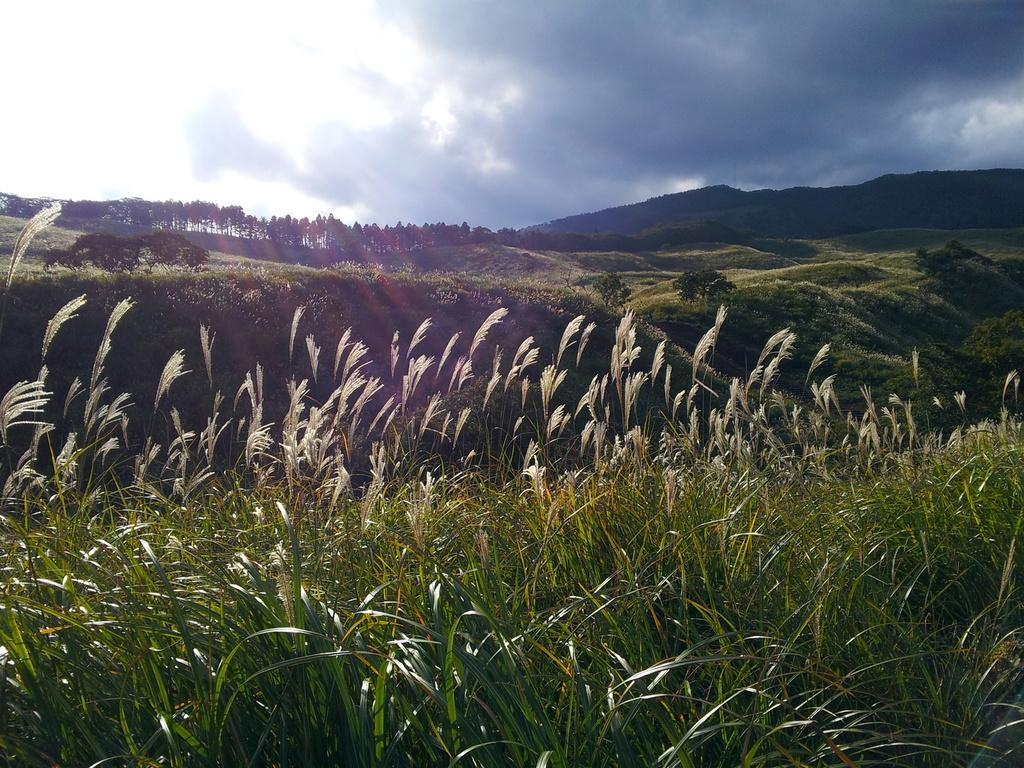What type of vegetation can be seen in the image? There are trees and plants in the image. What geographical features are present in the image? There are hills in the image. What is visible in the sky at the top of the image? There are clouds in the sky at the top of the image. What type of toothpaste is being used to water the plants in the image? There is no toothpaste present in the image; it features trees, plants, hills, and clouds. Can you describe the sofa that is visible in the image? There is no sofa present in the image. 